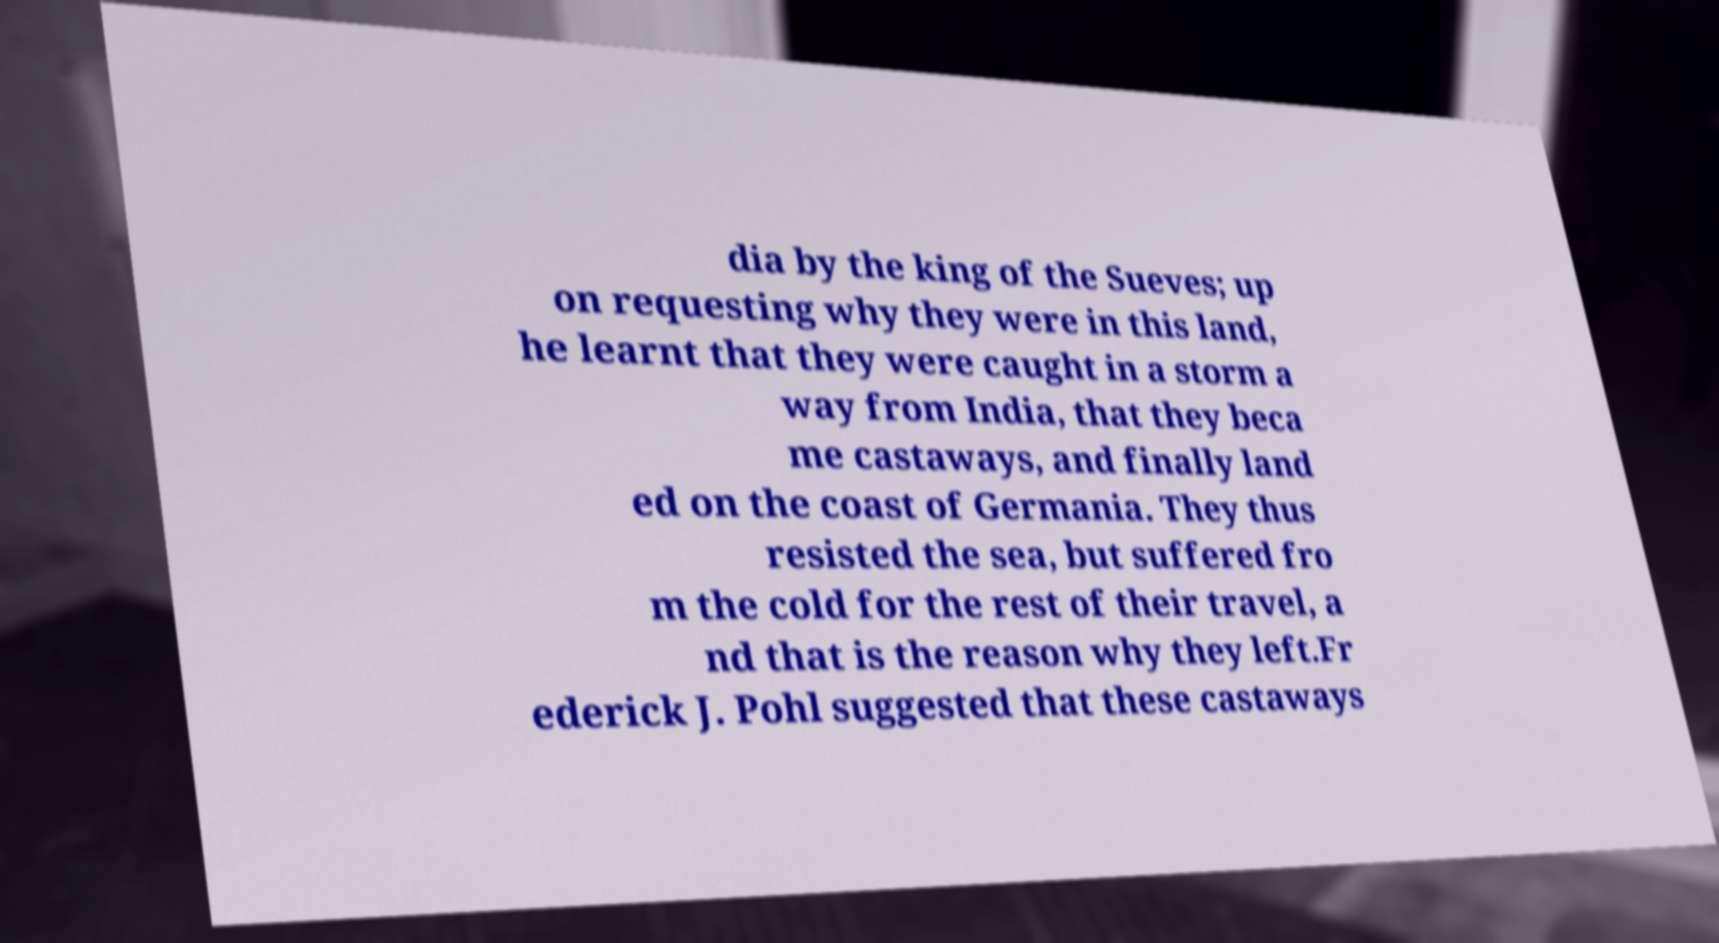Please identify and transcribe the text found in this image. dia by the king of the Sueves; up on requesting why they were in this land, he learnt that they were caught in a storm a way from India, that they beca me castaways, and finally land ed on the coast of Germania. They thus resisted the sea, but suffered fro m the cold for the rest of their travel, a nd that is the reason why they left.Fr ederick J. Pohl suggested that these castaways 